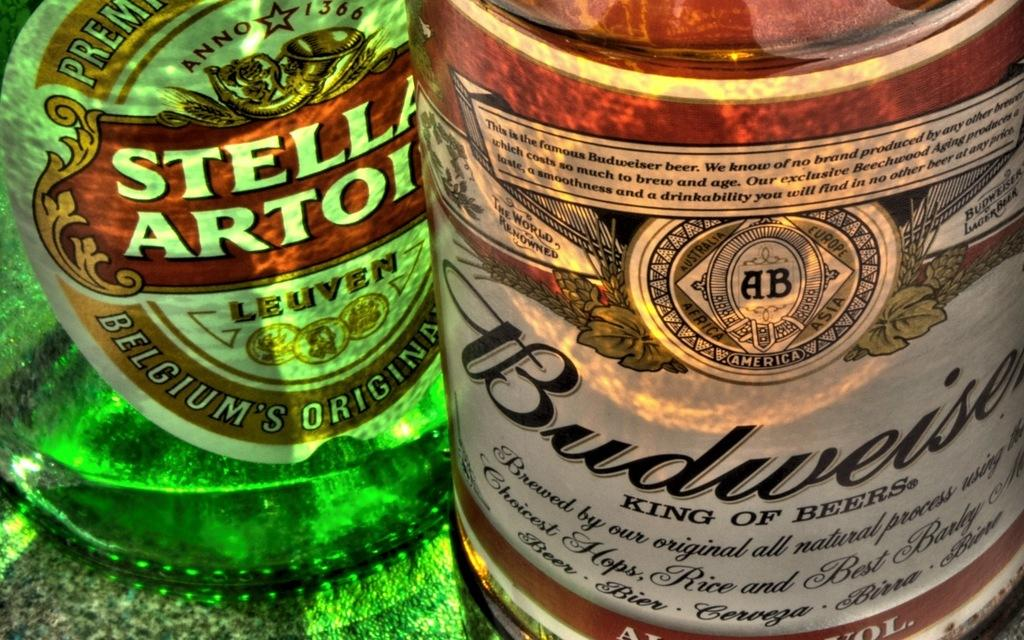<image>
Provide a brief description of the given image. A bottle from Belgium sits next to a Budweiser bottle. 